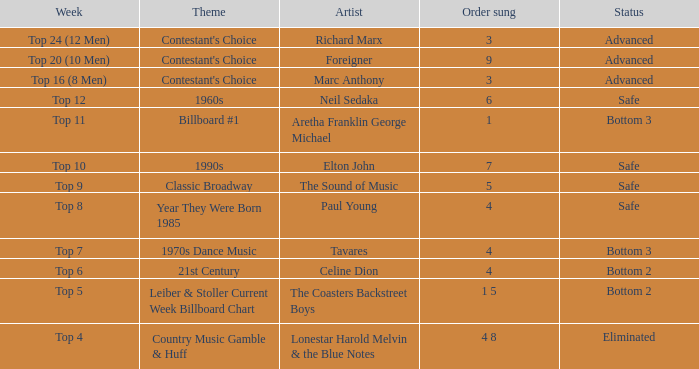During the week featuring billboard #1 theme, whose song was performed? Aretha Franklin George Michael. 